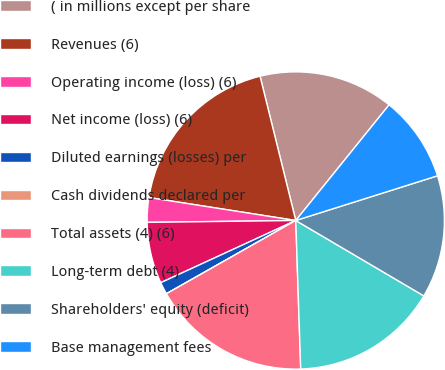Convert chart. <chart><loc_0><loc_0><loc_500><loc_500><pie_chart><fcel>( in millions except per share<fcel>Revenues (6)<fcel>Operating income (loss) (6)<fcel>Net income (loss) (6)<fcel>Diluted earnings (losses) per<fcel>Cash dividends declared per<fcel>Total assets (4) (6)<fcel>Long-term debt (4)<fcel>Shareholders' equity (deficit)<fcel>Base management fees<nl><fcel>14.67%<fcel>18.67%<fcel>2.67%<fcel>6.67%<fcel>1.33%<fcel>0.0%<fcel>17.33%<fcel>16.0%<fcel>13.33%<fcel>9.33%<nl></chart> 